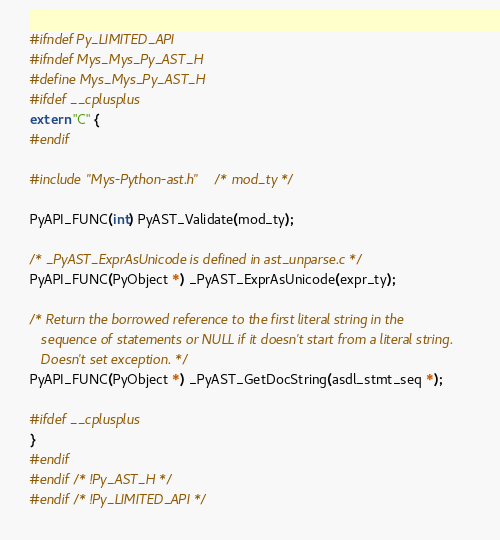<code> <loc_0><loc_0><loc_500><loc_500><_C_>#ifndef Py_LIMITED_API
#ifndef Mys_Mys_Py_AST_H
#define Mys_Mys_Py_AST_H
#ifdef __cplusplus
extern "C" {
#endif

#include "Mys-Python-ast.h"   /* mod_ty */

PyAPI_FUNC(int) PyAST_Validate(mod_ty);

/* _PyAST_ExprAsUnicode is defined in ast_unparse.c */
PyAPI_FUNC(PyObject *) _PyAST_ExprAsUnicode(expr_ty);

/* Return the borrowed reference to the first literal string in the
   sequence of statements or NULL if it doesn't start from a literal string.
   Doesn't set exception. */
PyAPI_FUNC(PyObject *) _PyAST_GetDocString(asdl_stmt_seq *);

#ifdef __cplusplus
}
#endif
#endif /* !Py_AST_H */
#endif /* !Py_LIMITED_API */
</code> 